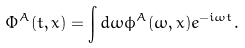Convert formula to latex. <formula><loc_0><loc_0><loc_500><loc_500>\Phi ^ { A } ( t , x ) = \int d \omega \phi ^ { A } ( \omega , x ) e ^ { - i \omega t } .</formula> 